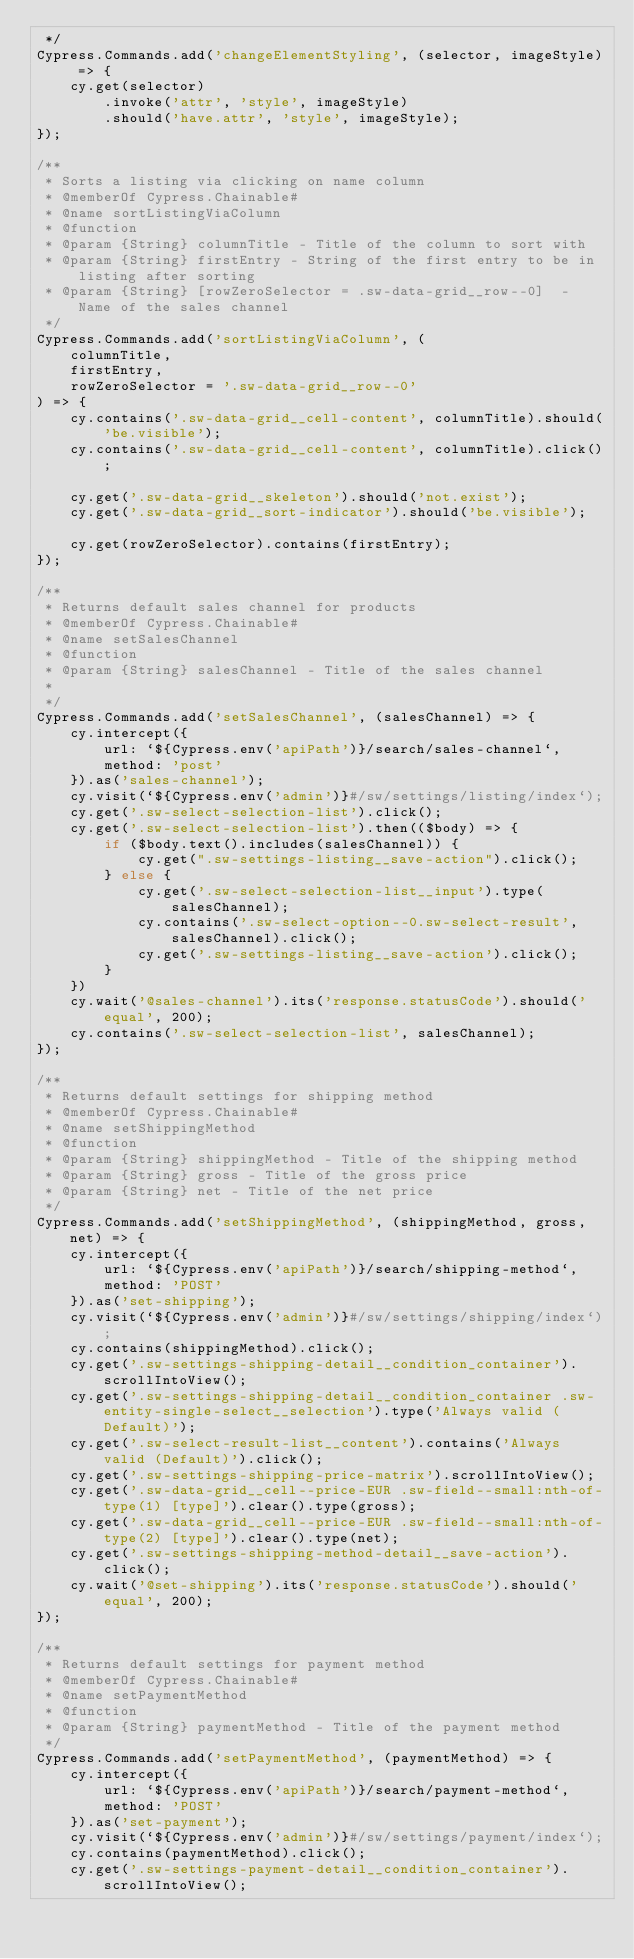<code> <loc_0><loc_0><loc_500><loc_500><_JavaScript_> */
Cypress.Commands.add('changeElementStyling', (selector, imageStyle) => {
    cy.get(selector)
        .invoke('attr', 'style', imageStyle)
        .should('have.attr', 'style', imageStyle);
});

/**
 * Sorts a listing via clicking on name column
 * @memberOf Cypress.Chainable#
 * @name sortListingViaColumn
 * @function
 * @param {String} columnTitle - Title of the column to sort with
 * @param {String} firstEntry - String of the first entry to be in listing after sorting
 * @param {String} [rowZeroSelector = .sw-data-grid__row--0]  - Name of the sales channel
 */
Cypress.Commands.add('sortListingViaColumn', (
    columnTitle,
    firstEntry,
    rowZeroSelector = '.sw-data-grid__row--0'
) => {
    cy.contains('.sw-data-grid__cell-content', columnTitle).should('be.visible');
    cy.contains('.sw-data-grid__cell-content', columnTitle).click();

    cy.get('.sw-data-grid__skeleton').should('not.exist');
    cy.get('.sw-data-grid__sort-indicator').should('be.visible');

    cy.get(rowZeroSelector).contains(firstEntry);
});

/**
 * Returns default sales channel for products
 * @memberOf Cypress.Chainable#
 * @name setSalesChannel
 * @function
 * @param {String} salesChannel - Title of the sales channel
 *
 */
Cypress.Commands.add('setSalesChannel', (salesChannel) => {
    cy.intercept({
        url: `${Cypress.env('apiPath')}/search/sales-channel`,
        method: 'post'
    }).as('sales-channel');
    cy.visit(`${Cypress.env('admin')}#/sw/settings/listing/index`);
    cy.get('.sw-select-selection-list').click();
    cy.get('.sw-select-selection-list').then(($body) => {
        if ($body.text().includes(salesChannel)) {
            cy.get(".sw-settings-listing__save-action").click();
        } else {
            cy.get('.sw-select-selection-list__input').type(salesChannel);
            cy.contains('.sw-select-option--0.sw-select-result', salesChannel).click();
            cy.get('.sw-settings-listing__save-action').click();
        }
    })
    cy.wait('@sales-channel').its('response.statusCode').should('equal', 200);
    cy.contains('.sw-select-selection-list', salesChannel);
});

/**
 * Returns default settings for shipping method
 * @memberOf Cypress.Chainable#
 * @name setShippingMethod
 * @function
 * @param {String} shippingMethod - Title of the shipping method
 * @param {String} gross - Title of the gross price
 * @param {String} net - Title of the net price
 */
Cypress.Commands.add('setShippingMethod', (shippingMethod, gross, net) => {
    cy.intercept({
        url: `${Cypress.env('apiPath')}/search/shipping-method`,
        method: 'POST'
    }).as('set-shipping');
    cy.visit(`${Cypress.env('admin')}#/sw/settings/shipping/index`);
    cy.contains(shippingMethod).click();
    cy.get('.sw-settings-shipping-detail__condition_container').scrollIntoView();
    cy.get('.sw-settings-shipping-detail__condition_container .sw-entity-single-select__selection').type('Always valid (Default)');
    cy.get('.sw-select-result-list__content').contains('Always valid (Default)').click();
    cy.get('.sw-settings-shipping-price-matrix').scrollIntoView();
    cy.get('.sw-data-grid__cell--price-EUR .sw-field--small:nth-of-type(1) [type]').clear().type(gross);
    cy.get('.sw-data-grid__cell--price-EUR .sw-field--small:nth-of-type(2) [type]').clear().type(net);
    cy.get('.sw-settings-shipping-method-detail__save-action').click();
    cy.wait('@set-shipping').its('response.statusCode').should('equal', 200);
});

/**
 * Returns default settings for payment method
 * @memberOf Cypress.Chainable#
 * @name setPaymentMethod
 * @function
 * @param {String} paymentMethod - Title of the payment method
 */
Cypress.Commands.add('setPaymentMethod', (paymentMethod) => {
    cy.intercept({
        url: `${Cypress.env('apiPath')}/search/payment-method`,
        method: 'POST'
    }).as('set-payment');
    cy.visit(`${Cypress.env('admin')}#/sw/settings/payment/index`);
    cy.contains(paymentMethod).click();
    cy.get('.sw-settings-payment-detail__condition_container').scrollIntoView();</code> 